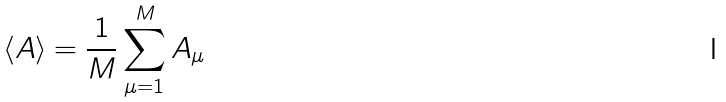Convert formula to latex. <formula><loc_0><loc_0><loc_500><loc_500>\langle A \rangle = \frac { 1 } { M } \sum _ { \mu = 1 } ^ { M } A _ { \mu }</formula> 